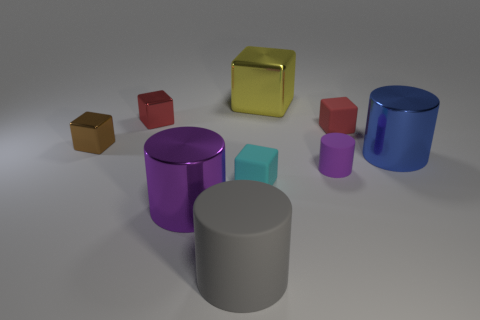What number of things are the same color as the small cylinder?
Give a very brief answer. 1. What is the shape of the tiny red metal thing in front of the big metal block?
Give a very brief answer. Cube. The purple cylinder that is left of the big gray rubber cylinder on the right side of the purple metal thing is made of what material?
Ensure brevity in your answer.  Metal. Are there more small cyan things in front of the tiny purple rubber cylinder than tiny cyan matte objects?
Keep it short and to the point. No. How many other objects are there of the same color as the big rubber object?
Provide a short and direct response. 0. There is a purple thing that is the same size as the gray rubber cylinder; what is its shape?
Your response must be concise. Cylinder. There is a metallic cube to the right of the purple cylinder that is left of the large gray cylinder; what number of blocks are in front of it?
Offer a terse response. 4. How many rubber objects are either tiny cyan objects or cylinders?
Offer a very short reply. 3. What is the color of the large shiny thing that is both in front of the tiny red rubber thing and left of the tiny red matte thing?
Keep it short and to the point. Purple. There is a rubber object that is in front of the cyan block; does it have the same size as the blue metal cylinder?
Your response must be concise. Yes. 